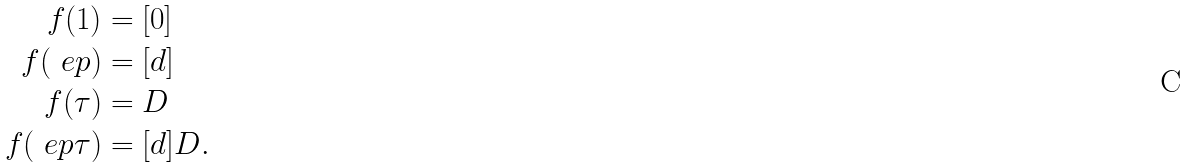<formula> <loc_0><loc_0><loc_500><loc_500>f ( 1 ) & = [ 0 ] \\ f ( \ e p ) & = [ d ] \\ f ( \tau ) & = D \\ f ( \ e p \tau ) & = [ d ] D .</formula> 